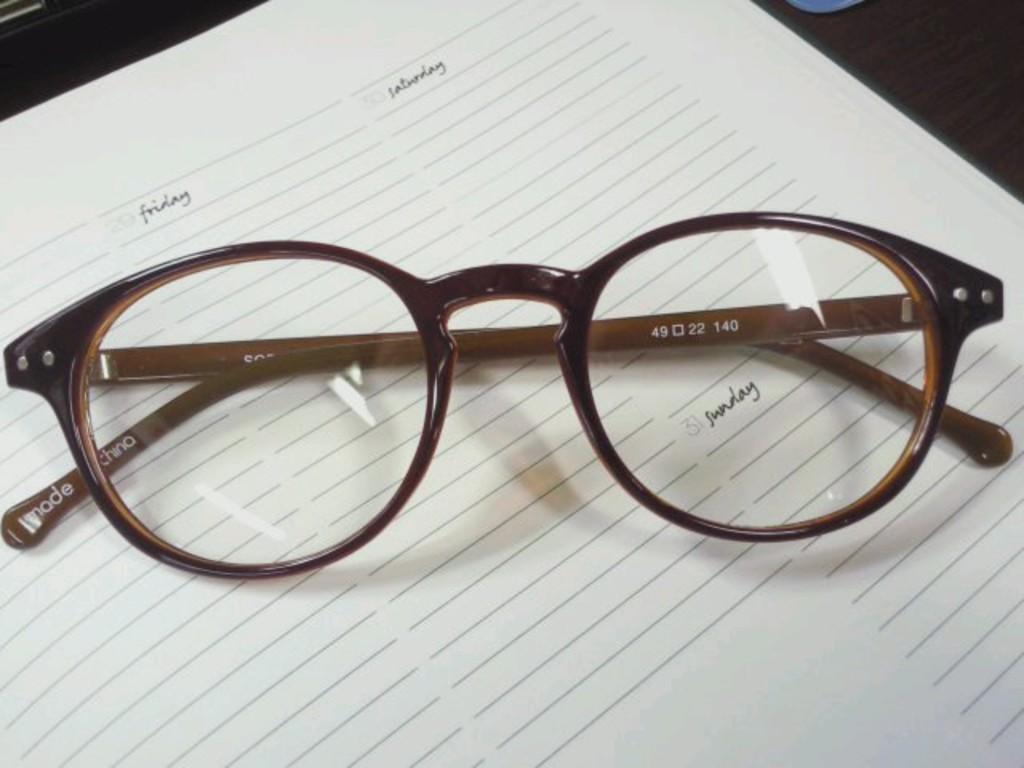Can you describe this image briefly? In this picture I can see there is a spectacle placed on the paper and there is something written on the paper, it is placed on the black color surface. 